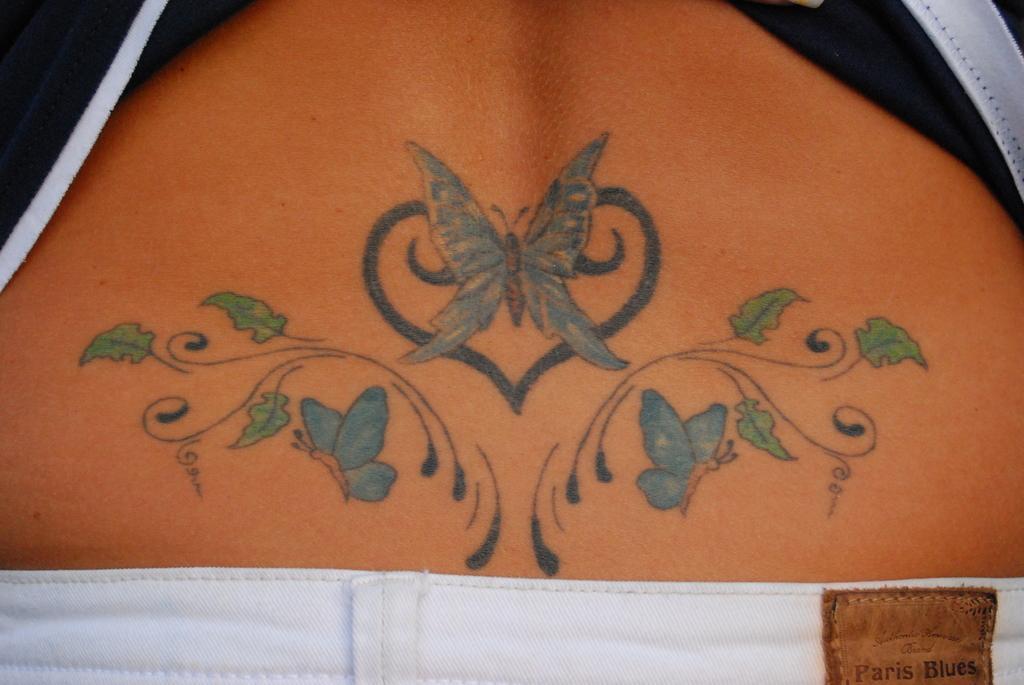In one or two sentences, can you explain what this image depicts? in this picture I can see the person's back who is a painted the butterfly and flowers. She is wearing t-shirt and trouser. 